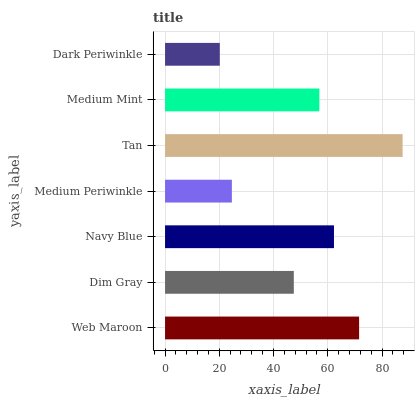Is Dark Periwinkle the minimum?
Answer yes or no. Yes. Is Tan the maximum?
Answer yes or no. Yes. Is Dim Gray the minimum?
Answer yes or no. No. Is Dim Gray the maximum?
Answer yes or no. No. Is Web Maroon greater than Dim Gray?
Answer yes or no. Yes. Is Dim Gray less than Web Maroon?
Answer yes or no. Yes. Is Dim Gray greater than Web Maroon?
Answer yes or no. No. Is Web Maroon less than Dim Gray?
Answer yes or no. No. Is Medium Mint the high median?
Answer yes or no. Yes. Is Medium Mint the low median?
Answer yes or no. Yes. Is Navy Blue the high median?
Answer yes or no. No. Is Medium Periwinkle the low median?
Answer yes or no. No. 